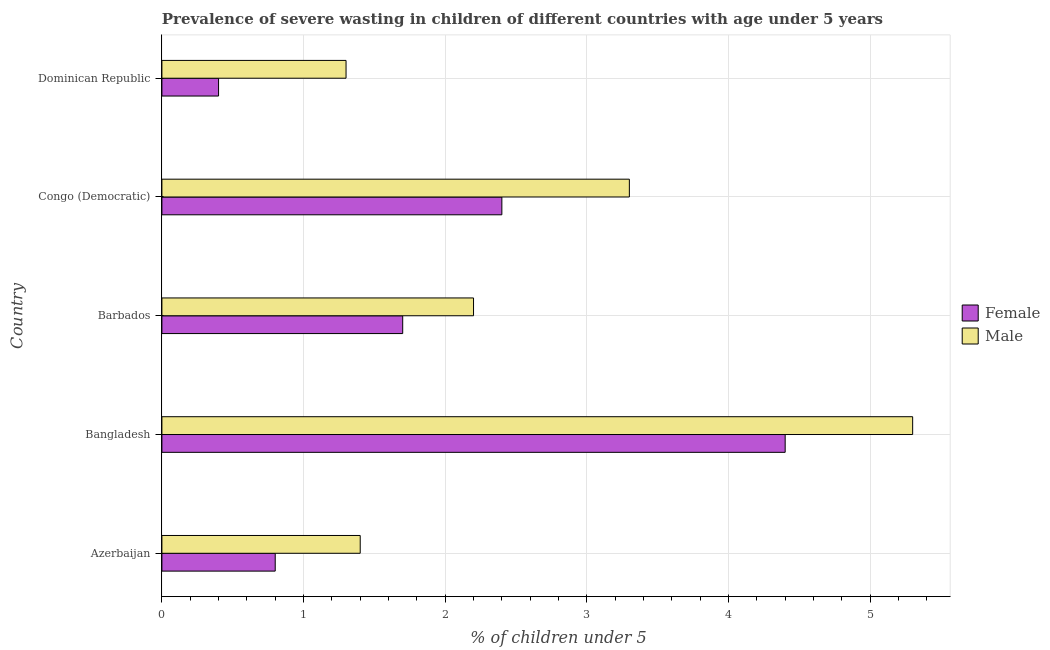How many groups of bars are there?
Offer a very short reply. 5. How many bars are there on the 2nd tick from the top?
Ensure brevity in your answer.  2. How many bars are there on the 3rd tick from the bottom?
Keep it short and to the point. 2. What is the label of the 1st group of bars from the top?
Keep it short and to the point. Dominican Republic. In how many cases, is the number of bars for a given country not equal to the number of legend labels?
Offer a terse response. 0. What is the percentage of undernourished male children in Bangladesh?
Keep it short and to the point. 5.3. Across all countries, what is the maximum percentage of undernourished male children?
Provide a succinct answer. 5.3. Across all countries, what is the minimum percentage of undernourished male children?
Your answer should be compact. 1.3. In which country was the percentage of undernourished female children maximum?
Your answer should be very brief. Bangladesh. In which country was the percentage of undernourished male children minimum?
Provide a short and direct response. Dominican Republic. What is the total percentage of undernourished male children in the graph?
Provide a succinct answer. 13.5. What is the difference between the percentage of undernourished male children in Azerbaijan and that in Dominican Republic?
Your response must be concise. 0.1. What is the difference between the percentage of undernourished female children in Dominican Republic and the percentage of undernourished male children in Congo (Democratic)?
Your answer should be compact. -2.9. What is the average percentage of undernourished female children per country?
Give a very brief answer. 1.94. What is the difference between the percentage of undernourished male children and percentage of undernourished female children in Azerbaijan?
Your answer should be very brief. 0.6. In how many countries, is the percentage of undernourished male children greater than 5.2 %?
Provide a short and direct response. 1. Is the percentage of undernourished female children in Azerbaijan less than that in Congo (Democratic)?
Offer a terse response. Yes. Is the difference between the percentage of undernourished female children in Bangladesh and Barbados greater than the difference between the percentage of undernourished male children in Bangladesh and Barbados?
Your answer should be compact. No. What is the difference between the highest and the second highest percentage of undernourished female children?
Offer a very short reply. 2. Is the sum of the percentage of undernourished female children in Bangladesh and Dominican Republic greater than the maximum percentage of undernourished male children across all countries?
Offer a terse response. No. What does the 1st bar from the bottom in Congo (Democratic) represents?
Provide a succinct answer. Female. How many bars are there?
Offer a very short reply. 10. Are all the bars in the graph horizontal?
Offer a terse response. Yes. How many countries are there in the graph?
Give a very brief answer. 5. What is the difference between two consecutive major ticks on the X-axis?
Provide a short and direct response. 1. Does the graph contain grids?
Ensure brevity in your answer.  Yes. Where does the legend appear in the graph?
Ensure brevity in your answer.  Center right. How many legend labels are there?
Ensure brevity in your answer.  2. How are the legend labels stacked?
Provide a short and direct response. Vertical. What is the title of the graph?
Your response must be concise. Prevalence of severe wasting in children of different countries with age under 5 years. What is the label or title of the X-axis?
Give a very brief answer.  % of children under 5. What is the  % of children under 5 in Female in Azerbaijan?
Give a very brief answer. 0.8. What is the  % of children under 5 in Male in Azerbaijan?
Your response must be concise. 1.4. What is the  % of children under 5 in Female in Bangladesh?
Provide a succinct answer. 4.4. What is the  % of children under 5 of Male in Bangladesh?
Ensure brevity in your answer.  5.3. What is the  % of children under 5 in Male in Barbados?
Your answer should be very brief. 2.2. What is the  % of children under 5 in Female in Congo (Democratic)?
Provide a short and direct response. 2.4. What is the  % of children under 5 in Male in Congo (Democratic)?
Ensure brevity in your answer.  3.3. What is the  % of children under 5 of Female in Dominican Republic?
Your answer should be compact. 0.4. What is the  % of children under 5 of Male in Dominican Republic?
Your response must be concise. 1.3. Across all countries, what is the maximum  % of children under 5 in Female?
Offer a very short reply. 4.4. Across all countries, what is the maximum  % of children under 5 in Male?
Provide a succinct answer. 5.3. Across all countries, what is the minimum  % of children under 5 in Female?
Offer a terse response. 0.4. Across all countries, what is the minimum  % of children under 5 in Male?
Provide a succinct answer. 1.3. What is the total  % of children under 5 in Male in the graph?
Offer a terse response. 13.5. What is the difference between the  % of children under 5 of Male in Azerbaijan and that in Bangladesh?
Provide a short and direct response. -3.9. What is the difference between the  % of children under 5 of Female in Azerbaijan and that in Barbados?
Make the answer very short. -0.9. What is the difference between the  % of children under 5 of Male in Azerbaijan and that in Barbados?
Offer a terse response. -0.8. What is the difference between the  % of children under 5 in Male in Azerbaijan and that in Congo (Democratic)?
Your answer should be very brief. -1.9. What is the difference between the  % of children under 5 of Male in Azerbaijan and that in Dominican Republic?
Provide a short and direct response. 0.1. What is the difference between the  % of children under 5 of Female in Bangladesh and that in Barbados?
Offer a terse response. 2.7. What is the difference between the  % of children under 5 in Male in Bangladesh and that in Barbados?
Your answer should be compact. 3.1. What is the difference between the  % of children under 5 in Female in Bangladesh and that in Congo (Democratic)?
Give a very brief answer. 2. What is the difference between the  % of children under 5 in Male in Bangladesh and that in Congo (Democratic)?
Offer a terse response. 2. What is the difference between the  % of children under 5 of Female in Barbados and that in Dominican Republic?
Your answer should be very brief. 1.3. What is the difference between the  % of children under 5 in Male in Congo (Democratic) and that in Dominican Republic?
Keep it short and to the point. 2. What is the difference between the  % of children under 5 of Female in Azerbaijan and the  % of children under 5 of Male in Barbados?
Offer a terse response. -1.4. What is the difference between the  % of children under 5 of Female in Azerbaijan and the  % of children under 5 of Male in Congo (Democratic)?
Provide a succinct answer. -2.5. What is the difference between the  % of children under 5 of Female in Azerbaijan and the  % of children under 5 of Male in Dominican Republic?
Provide a succinct answer. -0.5. What is the difference between the  % of children under 5 in Female in Barbados and the  % of children under 5 in Male in Congo (Democratic)?
Ensure brevity in your answer.  -1.6. What is the difference between the  % of children under 5 of Female in Barbados and the  % of children under 5 of Male in Dominican Republic?
Ensure brevity in your answer.  0.4. What is the difference between the  % of children under 5 in Female in Congo (Democratic) and the  % of children under 5 in Male in Dominican Republic?
Provide a succinct answer. 1.1. What is the average  % of children under 5 in Female per country?
Offer a terse response. 1.94. What is the difference between the  % of children under 5 of Female and  % of children under 5 of Male in Bangladesh?
Keep it short and to the point. -0.9. What is the ratio of the  % of children under 5 in Female in Azerbaijan to that in Bangladesh?
Ensure brevity in your answer.  0.18. What is the ratio of the  % of children under 5 of Male in Azerbaijan to that in Bangladesh?
Give a very brief answer. 0.26. What is the ratio of the  % of children under 5 in Female in Azerbaijan to that in Barbados?
Your answer should be compact. 0.47. What is the ratio of the  % of children under 5 of Male in Azerbaijan to that in Barbados?
Keep it short and to the point. 0.64. What is the ratio of the  % of children under 5 of Female in Azerbaijan to that in Congo (Democratic)?
Give a very brief answer. 0.33. What is the ratio of the  % of children under 5 in Male in Azerbaijan to that in Congo (Democratic)?
Your response must be concise. 0.42. What is the ratio of the  % of children under 5 of Female in Azerbaijan to that in Dominican Republic?
Provide a succinct answer. 2. What is the ratio of the  % of children under 5 of Male in Azerbaijan to that in Dominican Republic?
Your response must be concise. 1.08. What is the ratio of the  % of children under 5 of Female in Bangladesh to that in Barbados?
Offer a very short reply. 2.59. What is the ratio of the  % of children under 5 of Male in Bangladesh to that in Barbados?
Give a very brief answer. 2.41. What is the ratio of the  % of children under 5 of Female in Bangladesh to that in Congo (Democratic)?
Provide a succinct answer. 1.83. What is the ratio of the  % of children under 5 of Male in Bangladesh to that in Congo (Democratic)?
Offer a very short reply. 1.61. What is the ratio of the  % of children under 5 in Male in Bangladesh to that in Dominican Republic?
Your response must be concise. 4.08. What is the ratio of the  % of children under 5 of Female in Barbados to that in Congo (Democratic)?
Make the answer very short. 0.71. What is the ratio of the  % of children under 5 of Female in Barbados to that in Dominican Republic?
Ensure brevity in your answer.  4.25. What is the ratio of the  % of children under 5 of Male in Barbados to that in Dominican Republic?
Ensure brevity in your answer.  1.69. What is the ratio of the  % of children under 5 in Female in Congo (Democratic) to that in Dominican Republic?
Keep it short and to the point. 6. What is the ratio of the  % of children under 5 in Male in Congo (Democratic) to that in Dominican Republic?
Provide a succinct answer. 2.54. 